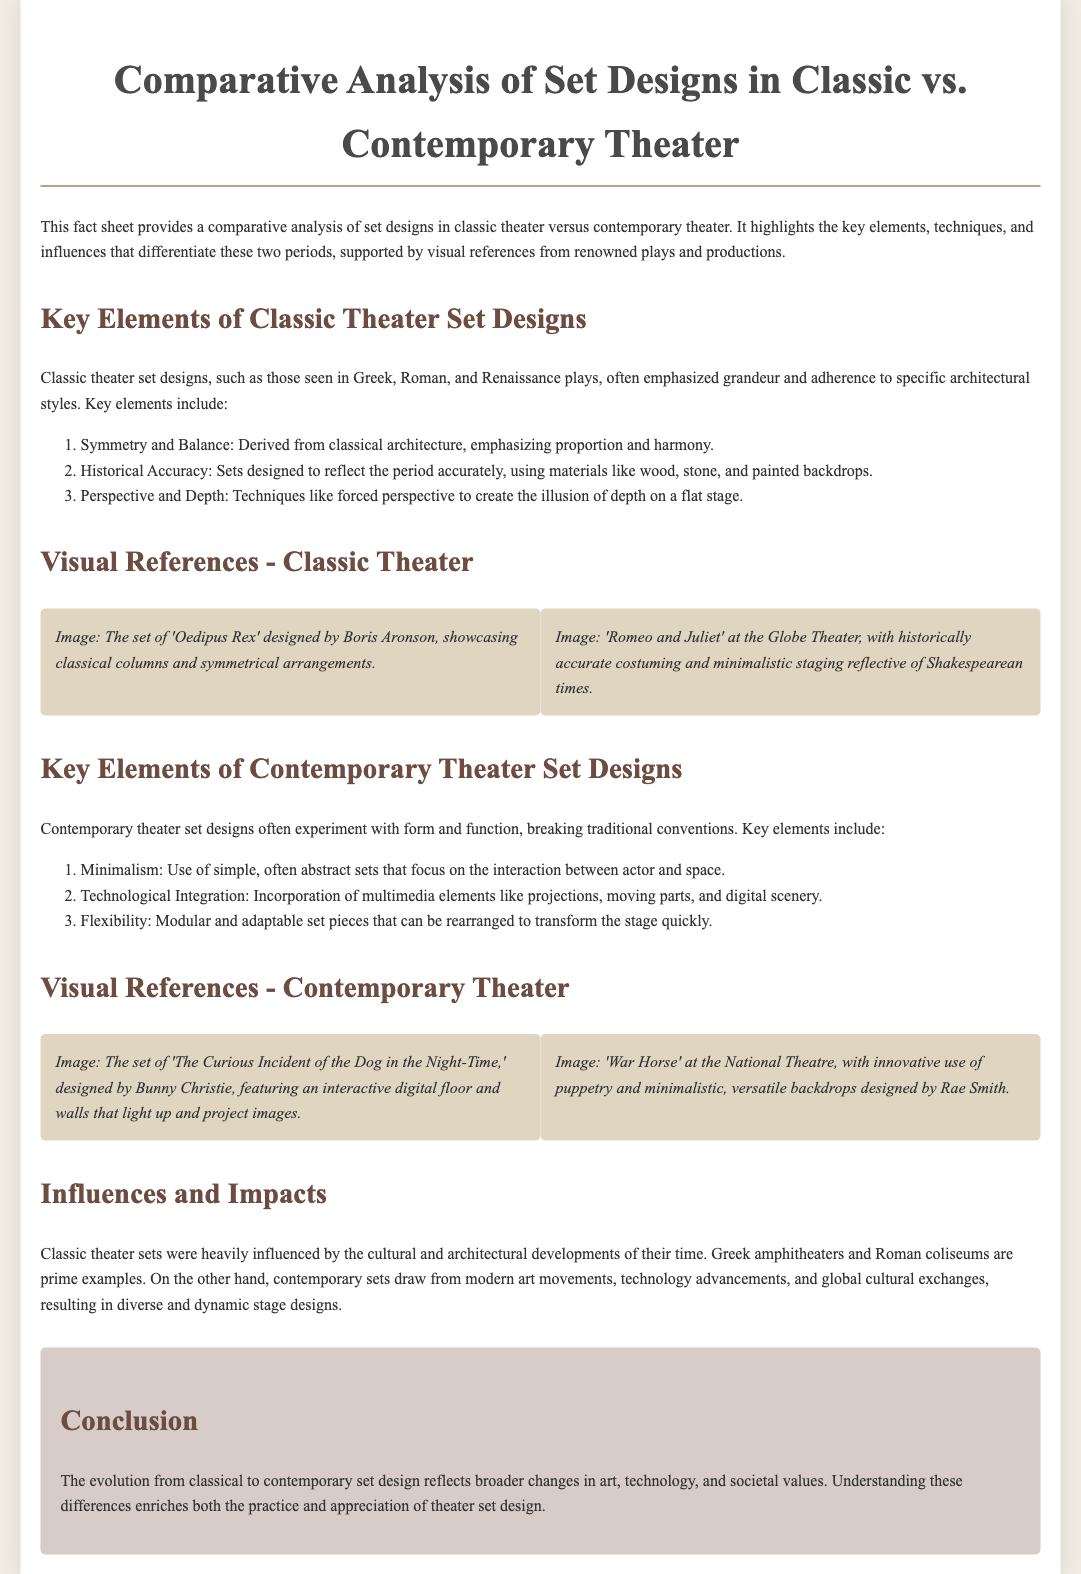What are the key elements of classic theater set designs? The document lists specific elements that define classic theater set designs, encompassing style, historical accuracy, and depth techniques.
Answer: Symmetry and Balance, Historical Accuracy, Perspective and Depth Who designed the set of 'The Curious Incident of the Dog in the Night-Time'? The document mentions the designer associated with this contemporary theater set as an example of innovative design.
Answer: Bunny Christie What technique is used in classic theater for creating the illusion of depth? The document identifies a specific method employed in classic theater set designs intended to enhance spatial perception.
Answer: Forced perspective What is a characteristic of contemporary theater set designs? The document outlines distinguishing traits of contemporary theater sets, specifically how they differ from classical designs.
Answer: Minimalism Which play featured innovative use of puppetry as highlighted in the visual references? The document references a particular production that exemplifies this technique through its stage design.
Answer: War Horse What is the main focus of contemporary set designs? The document discusses a prevalent theme or emphasis within the design philosophies of contemporary theater.
Answer: Interaction between actor and space What conclusion is drawn about the evolution of set design? The document provides a summary statement regarding the overall development and changes in set design through history.
Answer: Reflects broader changes in art, technology, and societal values 